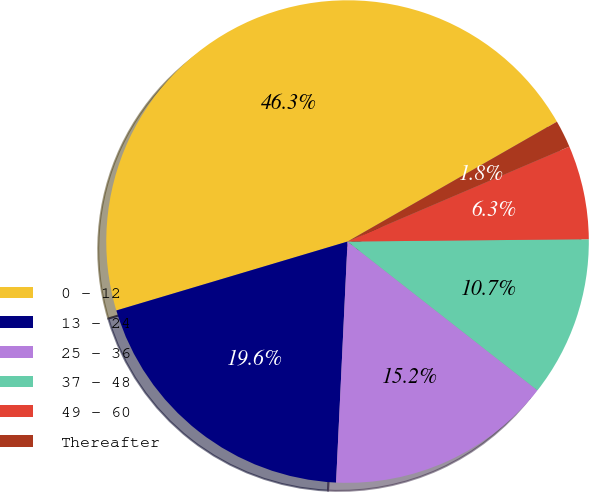<chart> <loc_0><loc_0><loc_500><loc_500><pie_chart><fcel>0 - 12<fcel>13 - 24<fcel>25 - 36<fcel>37 - 48<fcel>49 - 60<fcel>Thereafter<nl><fcel>46.33%<fcel>19.63%<fcel>15.18%<fcel>10.73%<fcel>6.28%<fcel>1.84%<nl></chart> 